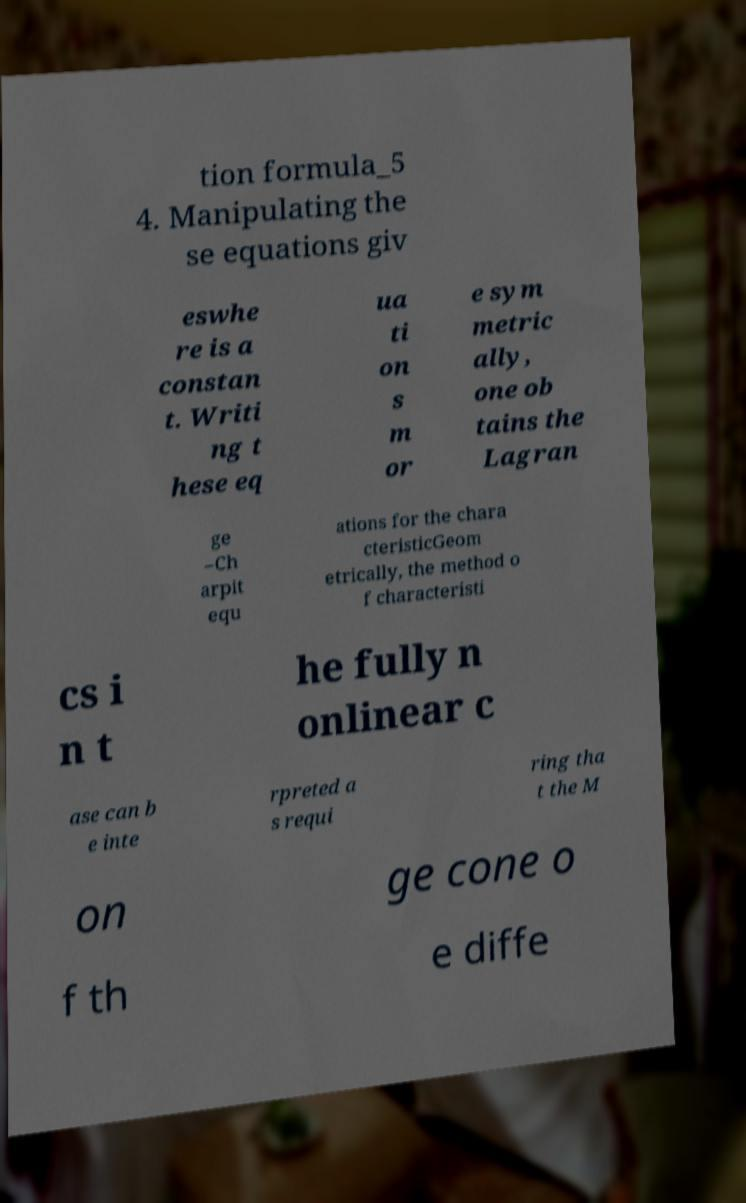Could you assist in decoding the text presented in this image and type it out clearly? tion formula_5 4. Manipulating the se equations giv eswhe re is a constan t. Writi ng t hese eq ua ti on s m or e sym metric ally, one ob tains the Lagran ge –Ch arpit equ ations for the chara cteristicGeom etrically, the method o f characteristi cs i n t he fully n onlinear c ase can b e inte rpreted a s requi ring tha t the M on ge cone o f th e diffe 